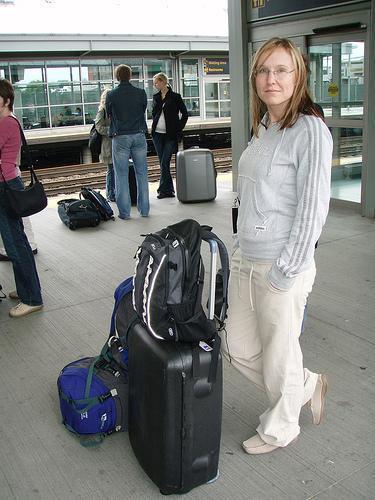How many people are standing?
Give a very brief answer. 5. How many black bags does the woman have?
Give a very brief answer. 2. How many people are pictured?
Give a very brief answer. 5. 